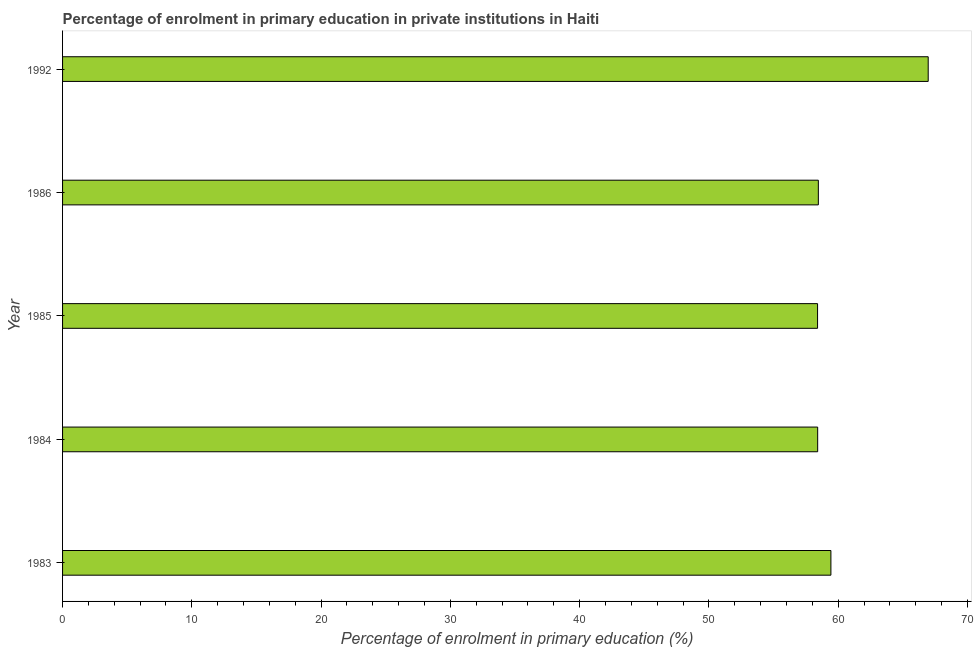Does the graph contain grids?
Keep it short and to the point. No. What is the title of the graph?
Your answer should be compact. Percentage of enrolment in primary education in private institutions in Haiti. What is the label or title of the X-axis?
Provide a short and direct response. Percentage of enrolment in primary education (%). What is the enrolment percentage in primary education in 1983?
Provide a succinct answer. 59.43. Across all years, what is the maximum enrolment percentage in primary education?
Your answer should be compact. 66.96. Across all years, what is the minimum enrolment percentage in primary education?
Your answer should be very brief. 58.4. In which year was the enrolment percentage in primary education maximum?
Ensure brevity in your answer.  1992. What is the sum of the enrolment percentage in primary education?
Your answer should be compact. 301.66. What is the difference between the enrolment percentage in primary education in 1983 and 1992?
Offer a terse response. -7.53. What is the average enrolment percentage in primary education per year?
Provide a succinct answer. 60.33. What is the median enrolment percentage in primary education?
Keep it short and to the point. 58.46. In how many years, is the enrolment percentage in primary education greater than 48 %?
Your answer should be very brief. 5. Do a majority of the years between 1986 and 1992 (inclusive) have enrolment percentage in primary education greater than 2 %?
Provide a succinct answer. Yes. What is the ratio of the enrolment percentage in primary education in 1983 to that in 1986?
Keep it short and to the point. 1.02. What is the difference between the highest and the second highest enrolment percentage in primary education?
Provide a short and direct response. 7.53. What is the difference between the highest and the lowest enrolment percentage in primary education?
Your response must be concise. 8.56. How many bars are there?
Provide a succinct answer. 5. How many years are there in the graph?
Give a very brief answer. 5. What is the Percentage of enrolment in primary education (%) in 1983?
Offer a terse response. 59.43. What is the Percentage of enrolment in primary education (%) of 1984?
Keep it short and to the point. 58.41. What is the Percentage of enrolment in primary education (%) in 1985?
Ensure brevity in your answer.  58.4. What is the Percentage of enrolment in primary education (%) in 1986?
Your response must be concise. 58.46. What is the Percentage of enrolment in primary education (%) of 1992?
Keep it short and to the point. 66.96. What is the difference between the Percentage of enrolment in primary education (%) in 1983 and 1984?
Provide a short and direct response. 1.02. What is the difference between the Percentage of enrolment in primary education (%) in 1983 and 1985?
Offer a terse response. 1.03. What is the difference between the Percentage of enrolment in primary education (%) in 1983 and 1986?
Offer a terse response. 0.97. What is the difference between the Percentage of enrolment in primary education (%) in 1983 and 1992?
Ensure brevity in your answer.  -7.53. What is the difference between the Percentage of enrolment in primary education (%) in 1984 and 1985?
Your response must be concise. 0.01. What is the difference between the Percentage of enrolment in primary education (%) in 1984 and 1986?
Offer a very short reply. -0.05. What is the difference between the Percentage of enrolment in primary education (%) in 1984 and 1992?
Your answer should be very brief. -8.55. What is the difference between the Percentage of enrolment in primary education (%) in 1985 and 1986?
Provide a succinct answer. -0.06. What is the difference between the Percentage of enrolment in primary education (%) in 1985 and 1992?
Your answer should be compact. -8.56. What is the difference between the Percentage of enrolment in primary education (%) in 1986 and 1992?
Give a very brief answer. -8.5. What is the ratio of the Percentage of enrolment in primary education (%) in 1983 to that in 1992?
Your answer should be very brief. 0.89. What is the ratio of the Percentage of enrolment in primary education (%) in 1984 to that in 1986?
Give a very brief answer. 1. What is the ratio of the Percentage of enrolment in primary education (%) in 1984 to that in 1992?
Your response must be concise. 0.87. What is the ratio of the Percentage of enrolment in primary education (%) in 1985 to that in 1986?
Ensure brevity in your answer.  1. What is the ratio of the Percentage of enrolment in primary education (%) in 1985 to that in 1992?
Make the answer very short. 0.87. What is the ratio of the Percentage of enrolment in primary education (%) in 1986 to that in 1992?
Make the answer very short. 0.87. 